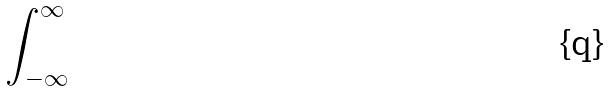<formula> <loc_0><loc_0><loc_500><loc_500>\int _ { - \infty } ^ { \infty }</formula> 